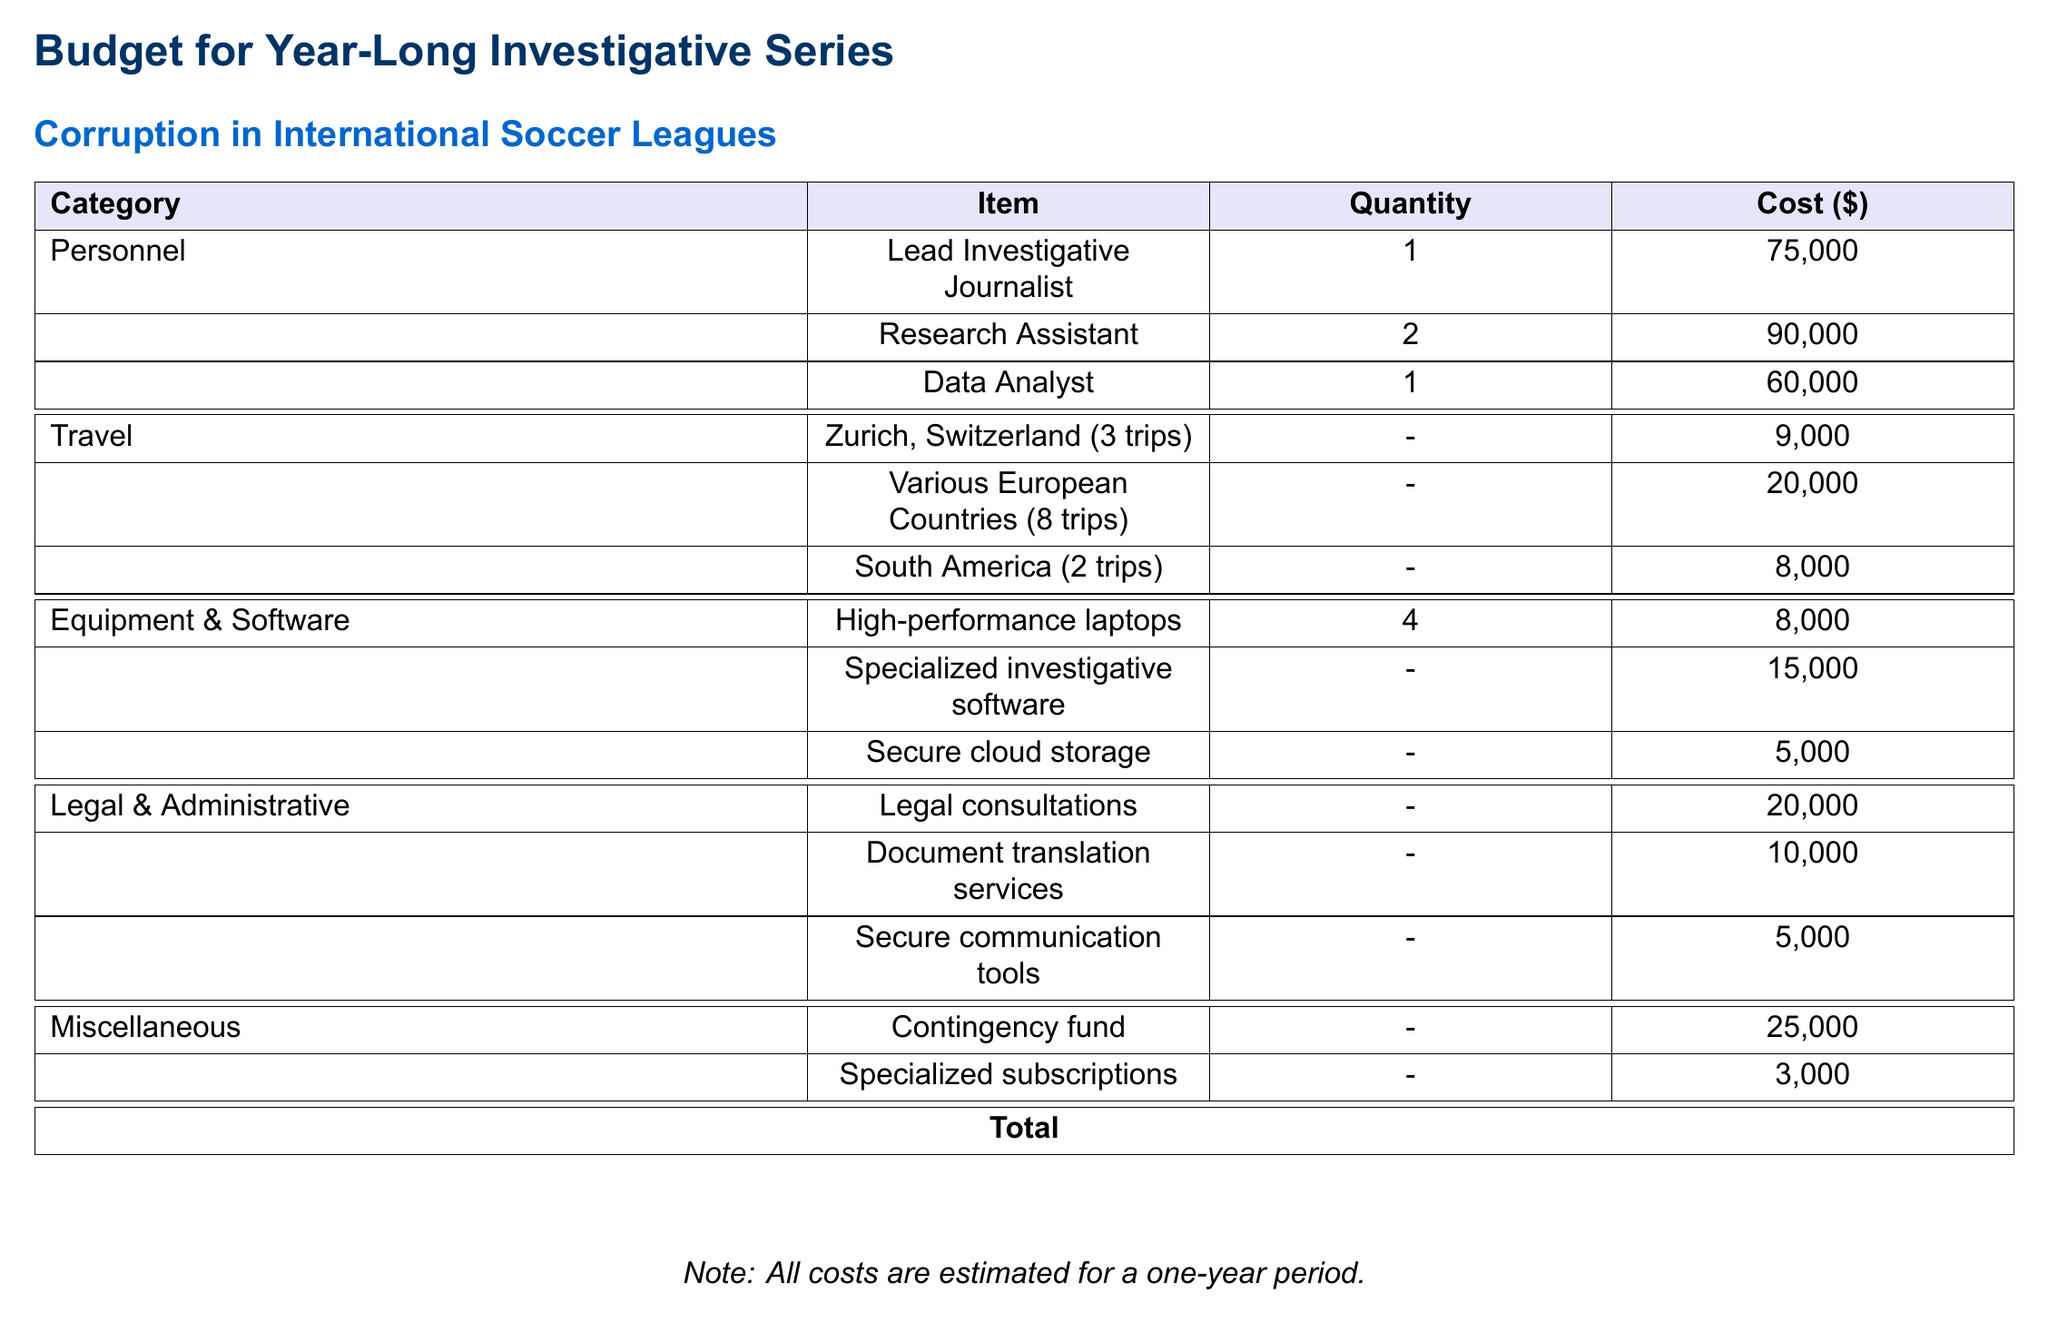What is the total estimated cost? The total estimated cost is mentioned in the document under the total line, which adds all expenses together.
Answer: 353,000 How much is allocated for legal consultations? The document specifies the cost allocated for legal consultations under the legal and administrative category.
Answer: 20,000 How many trips to Zurich, Switzerland are planned? The number of trips planned to Zurich is explicitly stated in the travel section of the document.
Answer: 3 What is the cost for secure cloud storage? The cost for secure cloud storage is directly listed in the equipment and software section of the budget.
Answer: 5,000 How many personnel are involved in the investigative series? The document includes a list of personnel under the personnel category, allowing for a count of individuals.
Answer: 4 What is the cost of the contingency fund? The cost of the contingency fund is provided under the miscellaneous category of the budget.
Answer: 25,000 What is the total cost for travel to various European countries? The total cost for travel to various European countries is specified in the travel section.
Answer: 20,000 How many high-performance laptops are being purchased? The document indicates the quantity of high-performance laptops needed in the equipment section.
Answer: 4 What budget category does document translation services fall under? The document translation services are listed under the legal and administrative category.
Answer: Legal & Administrative 